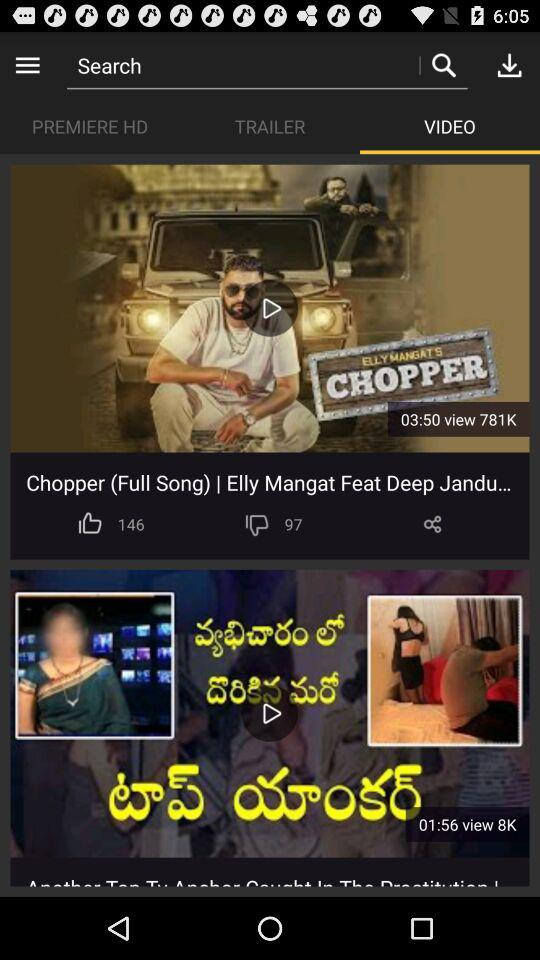How many views in total are of "Chopper (Full Song)"? There are 781K views of "Chopper (Full Song)" in total. 